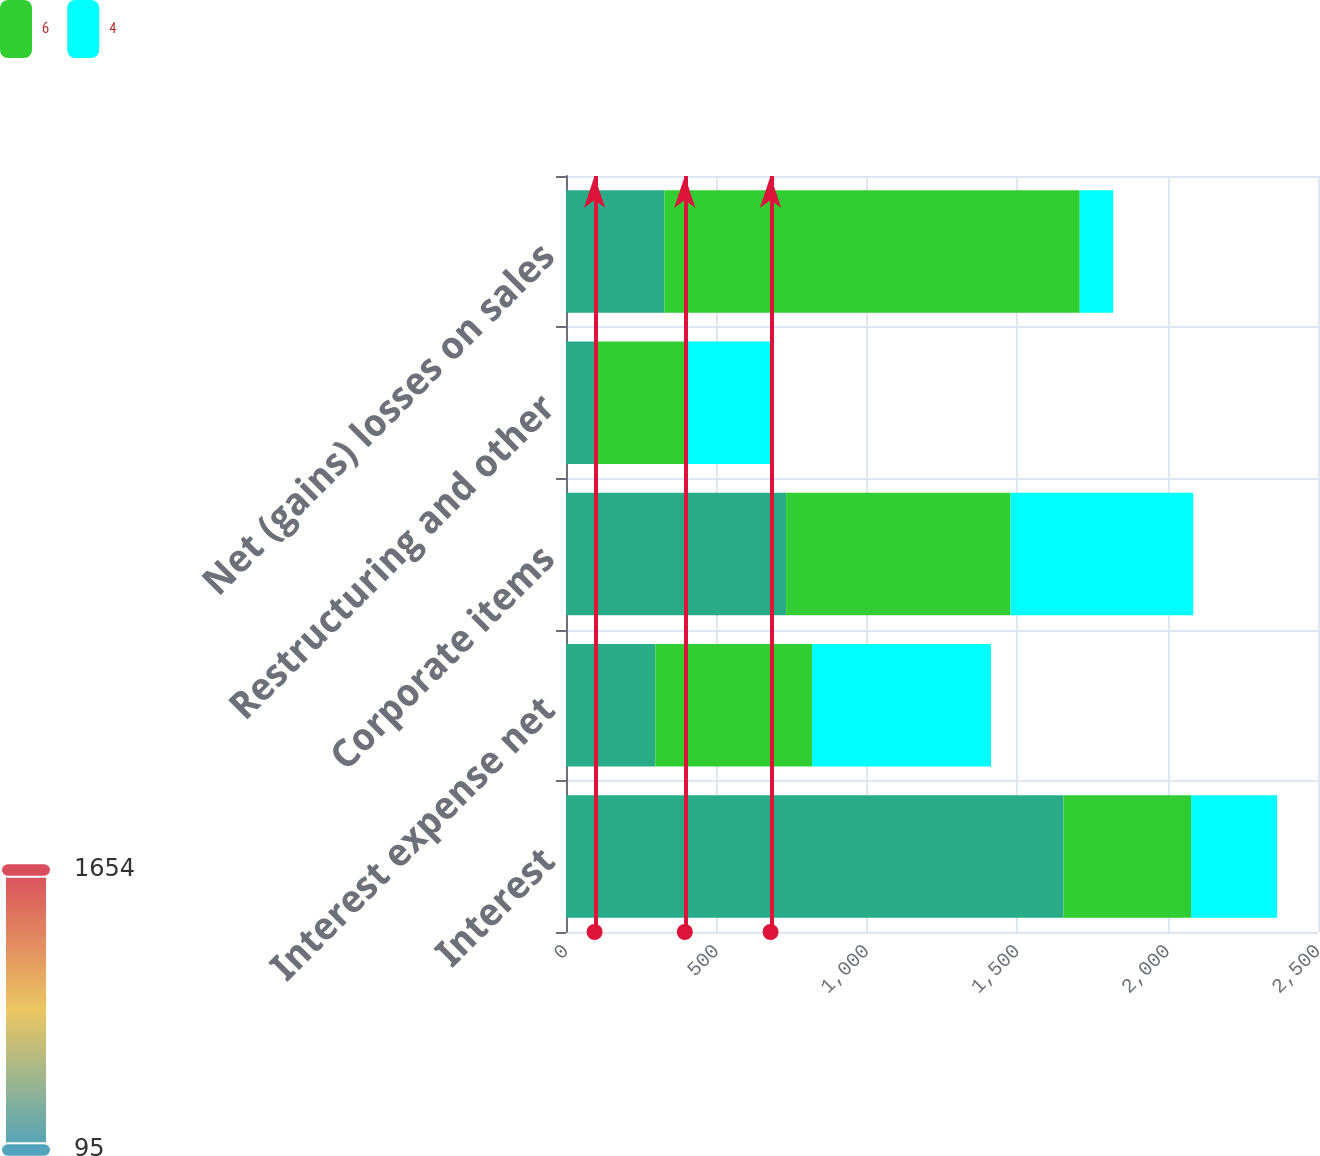Convert chart to OTSL. <chart><loc_0><loc_0><loc_500><loc_500><stacked_bar_chart><ecel><fcel>Interest<fcel>Interest expense net<fcel>Corporate items<fcel>Restructuring and other<fcel>Net (gains) losses on sales<nl><fcel>nan<fcel>1654<fcel>297<fcel>732<fcel>95<fcel>327<nl><fcel>6<fcel>424<fcel>521<fcel>746<fcel>300<fcel>1381<nl><fcel>4<fcel>286<fcel>595<fcel>607<fcel>285<fcel>111<nl></chart> 